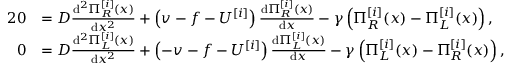<formula> <loc_0><loc_0><loc_500><loc_500>\begin{array} { r l } { { 2 } 0 } & { = D \frac { d ^ { 2 } \Pi _ { R } ^ { [ i ] } ( x ) } { d x ^ { 2 } } + \left ( v - f - U ^ { [ i ] } \right ) \frac { d \Pi _ { R } ^ { [ i ] } ( x ) } { d x } - \gamma \left ( \Pi _ { R } ^ { [ i ] } ( x ) - \Pi _ { L } ^ { [ i ] } ( x ) \right ) , } \\ { 0 } & { = D \frac { d ^ { 2 } \Pi _ { L } ^ { [ i ] } ( x ) } { d x ^ { 2 } } + \left ( - v - f - U ^ { [ i ] } \right ) \frac { d \Pi _ { L } ^ { [ i ] } ( x ) } { d x } - \gamma \left ( \Pi _ { L } ^ { [ i ] } ( x ) - \Pi _ { R } ^ { [ i ] } ( x ) \right ) , } \end{array}</formula> 